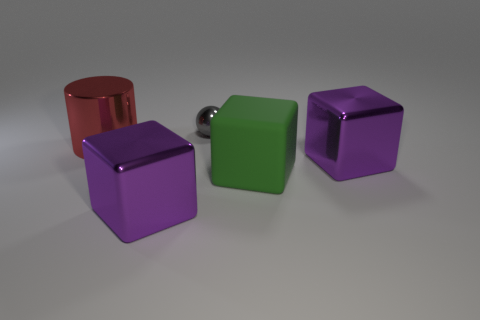Is there a large purple thing that has the same material as the gray sphere?
Ensure brevity in your answer.  Yes. Is the small sphere made of the same material as the green block that is in front of the small metallic ball?
Your answer should be compact. No. There is a rubber thing that is the same size as the cylinder; what is its color?
Your response must be concise. Green. There is a rubber object that is in front of the metallic object that is behind the big metallic cylinder; how big is it?
Ensure brevity in your answer.  Large. Are there fewer red things left of the large green object than large metallic cylinders?
Provide a short and direct response. No. What number of other objects are the same size as the green thing?
Make the answer very short. 3. There is a purple shiny thing in front of the green rubber object; is it the same shape as the large green object?
Provide a short and direct response. Yes. Are there more purple metallic blocks that are on the left side of the tiny gray object than tiny purple metallic cylinders?
Provide a short and direct response. Yes. The thing that is behind the green rubber block and on the right side of the small shiny ball is made of what material?
Offer a terse response. Metal. Is there anything else that has the same shape as the tiny thing?
Ensure brevity in your answer.  No. 